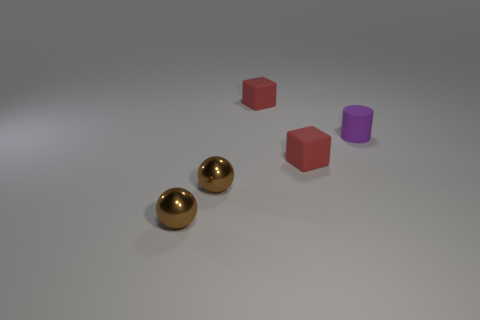Subtract all cylinders. How many objects are left? 4 Add 2 blue shiny blocks. How many objects exist? 7 Subtract all red matte things. Subtract all purple matte cylinders. How many objects are left? 2 Add 3 balls. How many balls are left? 5 Add 2 matte objects. How many matte objects exist? 5 Subtract 0 blue spheres. How many objects are left? 5 Subtract 2 balls. How many balls are left? 0 Subtract all gray cylinders. Subtract all green spheres. How many cylinders are left? 1 